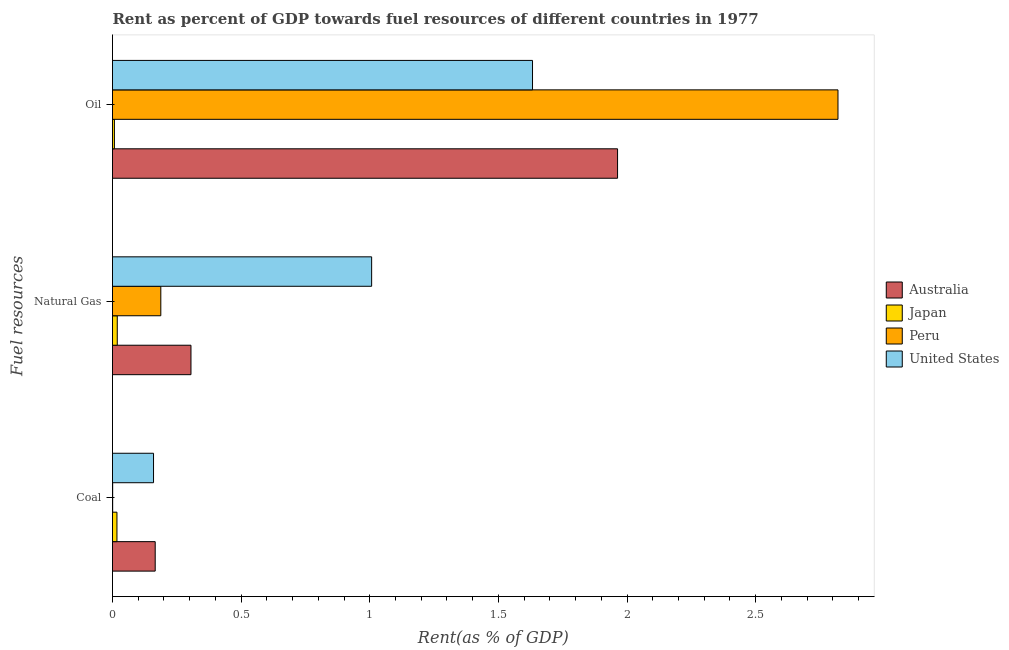How many groups of bars are there?
Provide a succinct answer. 3. What is the label of the 1st group of bars from the top?
Give a very brief answer. Oil. What is the rent towards oil in Japan?
Provide a succinct answer. 0.01. Across all countries, what is the maximum rent towards coal?
Provide a succinct answer. 0.17. Across all countries, what is the minimum rent towards natural gas?
Provide a succinct answer. 0.02. In which country was the rent towards oil maximum?
Your response must be concise. Peru. What is the total rent towards natural gas in the graph?
Offer a terse response. 1.52. What is the difference between the rent towards natural gas in United States and that in Australia?
Keep it short and to the point. 0.7. What is the difference between the rent towards coal in Peru and the rent towards natural gas in United States?
Your answer should be very brief. -1.01. What is the average rent towards oil per country?
Provide a succinct answer. 1.61. What is the difference between the rent towards natural gas and rent towards coal in Australia?
Give a very brief answer. 0.14. In how many countries, is the rent towards coal greater than 0.5 %?
Keep it short and to the point. 0. What is the ratio of the rent towards coal in Japan to that in United States?
Your answer should be compact. 0.11. What is the difference between the highest and the second highest rent towards natural gas?
Give a very brief answer. 0.7. What is the difference between the highest and the lowest rent towards coal?
Give a very brief answer. 0.17. In how many countries, is the rent towards natural gas greater than the average rent towards natural gas taken over all countries?
Keep it short and to the point. 1. Is the sum of the rent towards natural gas in Japan and United States greater than the maximum rent towards coal across all countries?
Your answer should be very brief. Yes. What does the 3rd bar from the bottom in Natural Gas represents?
Provide a succinct answer. Peru. Are all the bars in the graph horizontal?
Offer a terse response. Yes. Does the graph contain any zero values?
Your answer should be compact. No. Does the graph contain grids?
Ensure brevity in your answer.  No. What is the title of the graph?
Offer a very short reply. Rent as percent of GDP towards fuel resources of different countries in 1977. What is the label or title of the X-axis?
Offer a terse response. Rent(as % of GDP). What is the label or title of the Y-axis?
Give a very brief answer. Fuel resources. What is the Rent(as % of GDP) in Australia in Coal?
Provide a succinct answer. 0.17. What is the Rent(as % of GDP) of Japan in Coal?
Your answer should be very brief. 0.02. What is the Rent(as % of GDP) of Peru in Coal?
Provide a short and direct response. 0. What is the Rent(as % of GDP) in United States in Coal?
Your answer should be compact. 0.16. What is the Rent(as % of GDP) in Australia in Natural Gas?
Provide a short and direct response. 0.31. What is the Rent(as % of GDP) of Japan in Natural Gas?
Provide a succinct answer. 0.02. What is the Rent(as % of GDP) in Peru in Natural Gas?
Your answer should be very brief. 0.19. What is the Rent(as % of GDP) in United States in Natural Gas?
Provide a succinct answer. 1.01. What is the Rent(as % of GDP) of Australia in Oil?
Keep it short and to the point. 1.96. What is the Rent(as % of GDP) of Japan in Oil?
Give a very brief answer. 0.01. What is the Rent(as % of GDP) of Peru in Oil?
Your answer should be very brief. 2.82. What is the Rent(as % of GDP) of United States in Oil?
Offer a terse response. 1.63. Across all Fuel resources, what is the maximum Rent(as % of GDP) of Australia?
Your answer should be very brief. 1.96. Across all Fuel resources, what is the maximum Rent(as % of GDP) in Japan?
Offer a terse response. 0.02. Across all Fuel resources, what is the maximum Rent(as % of GDP) of Peru?
Provide a short and direct response. 2.82. Across all Fuel resources, what is the maximum Rent(as % of GDP) of United States?
Your answer should be compact. 1.63. Across all Fuel resources, what is the minimum Rent(as % of GDP) of Australia?
Give a very brief answer. 0.17. Across all Fuel resources, what is the minimum Rent(as % of GDP) of Japan?
Offer a very short reply. 0.01. Across all Fuel resources, what is the minimum Rent(as % of GDP) of Peru?
Your answer should be very brief. 0. Across all Fuel resources, what is the minimum Rent(as % of GDP) of United States?
Offer a terse response. 0.16. What is the total Rent(as % of GDP) of Australia in the graph?
Keep it short and to the point. 2.43. What is the total Rent(as % of GDP) of Japan in the graph?
Your response must be concise. 0.04. What is the total Rent(as % of GDP) of Peru in the graph?
Your response must be concise. 3.01. What is the total Rent(as % of GDP) of United States in the graph?
Provide a short and direct response. 2.8. What is the difference between the Rent(as % of GDP) in Australia in Coal and that in Natural Gas?
Keep it short and to the point. -0.14. What is the difference between the Rent(as % of GDP) of Japan in Coal and that in Natural Gas?
Make the answer very short. -0. What is the difference between the Rent(as % of GDP) of Peru in Coal and that in Natural Gas?
Give a very brief answer. -0.19. What is the difference between the Rent(as % of GDP) in United States in Coal and that in Natural Gas?
Ensure brevity in your answer.  -0.85. What is the difference between the Rent(as % of GDP) in Australia in Coal and that in Oil?
Provide a short and direct response. -1.8. What is the difference between the Rent(as % of GDP) of Japan in Coal and that in Oil?
Offer a terse response. 0.01. What is the difference between the Rent(as % of GDP) in Peru in Coal and that in Oil?
Give a very brief answer. -2.82. What is the difference between the Rent(as % of GDP) of United States in Coal and that in Oil?
Make the answer very short. -1.47. What is the difference between the Rent(as % of GDP) of Australia in Natural Gas and that in Oil?
Provide a short and direct response. -1.66. What is the difference between the Rent(as % of GDP) in Japan in Natural Gas and that in Oil?
Your response must be concise. 0.01. What is the difference between the Rent(as % of GDP) in Peru in Natural Gas and that in Oil?
Offer a very short reply. -2.63. What is the difference between the Rent(as % of GDP) of United States in Natural Gas and that in Oil?
Give a very brief answer. -0.63. What is the difference between the Rent(as % of GDP) of Australia in Coal and the Rent(as % of GDP) of Japan in Natural Gas?
Your answer should be very brief. 0.15. What is the difference between the Rent(as % of GDP) of Australia in Coal and the Rent(as % of GDP) of Peru in Natural Gas?
Give a very brief answer. -0.02. What is the difference between the Rent(as % of GDP) of Australia in Coal and the Rent(as % of GDP) of United States in Natural Gas?
Make the answer very short. -0.84. What is the difference between the Rent(as % of GDP) in Japan in Coal and the Rent(as % of GDP) in Peru in Natural Gas?
Ensure brevity in your answer.  -0.17. What is the difference between the Rent(as % of GDP) of Japan in Coal and the Rent(as % of GDP) of United States in Natural Gas?
Make the answer very short. -0.99. What is the difference between the Rent(as % of GDP) of Peru in Coal and the Rent(as % of GDP) of United States in Natural Gas?
Give a very brief answer. -1.01. What is the difference between the Rent(as % of GDP) in Australia in Coal and the Rent(as % of GDP) in Japan in Oil?
Your answer should be very brief. 0.16. What is the difference between the Rent(as % of GDP) in Australia in Coal and the Rent(as % of GDP) in Peru in Oil?
Keep it short and to the point. -2.65. What is the difference between the Rent(as % of GDP) of Australia in Coal and the Rent(as % of GDP) of United States in Oil?
Make the answer very short. -1.47. What is the difference between the Rent(as % of GDP) of Japan in Coal and the Rent(as % of GDP) of Peru in Oil?
Provide a short and direct response. -2.8. What is the difference between the Rent(as % of GDP) of Japan in Coal and the Rent(as % of GDP) of United States in Oil?
Ensure brevity in your answer.  -1.62. What is the difference between the Rent(as % of GDP) in Peru in Coal and the Rent(as % of GDP) in United States in Oil?
Make the answer very short. -1.63. What is the difference between the Rent(as % of GDP) of Australia in Natural Gas and the Rent(as % of GDP) of Japan in Oil?
Offer a very short reply. 0.3. What is the difference between the Rent(as % of GDP) in Australia in Natural Gas and the Rent(as % of GDP) in Peru in Oil?
Offer a very short reply. -2.52. What is the difference between the Rent(as % of GDP) in Australia in Natural Gas and the Rent(as % of GDP) in United States in Oil?
Make the answer very short. -1.33. What is the difference between the Rent(as % of GDP) of Japan in Natural Gas and the Rent(as % of GDP) of Peru in Oil?
Give a very brief answer. -2.8. What is the difference between the Rent(as % of GDP) of Japan in Natural Gas and the Rent(as % of GDP) of United States in Oil?
Give a very brief answer. -1.61. What is the difference between the Rent(as % of GDP) in Peru in Natural Gas and the Rent(as % of GDP) in United States in Oil?
Provide a short and direct response. -1.44. What is the average Rent(as % of GDP) of Australia per Fuel resources?
Your response must be concise. 0.81. What is the average Rent(as % of GDP) of Japan per Fuel resources?
Offer a terse response. 0.01. What is the average Rent(as % of GDP) of United States per Fuel resources?
Your answer should be very brief. 0.93. What is the difference between the Rent(as % of GDP) in Australia and Rent(as % of GDP) in Japan in Coal?
Ensure brevity in your answer.  0.15. What is the difference between the Rent(as % of GDP) in Australia and Rent(as % of GDP) in Peru in Coal?
Provide a short and direct response. 0.17. What is the difference between the Rent(as % of GDP) of Australia and Rent(as % of GDP) of United States in Coal?
Provide a short and direct response. 0.01. What is the difference between the Rent(as % of GDP) of Japan and Rent(as % of GDP) of Peru in Coal?
Ensure brevity in your answer.  0.02. What is the difference between the Rent(as % of GDP) in Japan and Rent(as % of GDP) in United States in Coal?
Provide a short and direct response. -0.14. What is the difference between the Rent(as % of GDP) in Peru and Rent(as % of GDP) in United States in Coal?
Your answer should be very brief. -0.16. What is the difference between the Rent(as % of GDP) of Australia and Rent(as % of GDP) of Japan in Natural Gas?
Offer a terse response. 0.29. What is the difference between the Rent(as % of GDP) in Australia and Rent(as % of GDP) in Peru in Natural Gas?
Your answer should be compact. 0.12. What is the difference between the Rent(as % of GDP) in Australia and Rent(as % of GDP) in United States in Natural Gas?
Provide a short and direct response. -0.7. What is the difference between the Rent(as % of GDP) in Japan and Rent(as % of GDP) in Peru in Natural Gas?
Your response must be concise. -0.17. What is the difference between the Rent(as % of GDP) of Japan and Rent(as % of GDP) of United States in Natural Gas?
Your response must be concise. -0.99. What is the difference between the Rent(as % of GDP) of Peru and Rent(as % of GDP) of United States in Natural Gas?
Your response must be concise. -0.82. What is the difference between the Rent(as % of GDP) in Australia and Rent(as % of GDP) in Japan in Oil?
Provide a succinct answer. 1.96. What is the difference between the Rent(as % of GDP) of Australia and Rent(as % of GDP) of Peru in Oil?
Give a very brief answer. -0.86. What is the difference between the Rent(as % of GDP) of Australia and Rent(as % of GDP) of United States in Oil?
Your response must be concise. 0.33. What is the difference between the Rent(as % of GDP) of Japan and Rent(as % of GDP) of Peru in Oil?
Offer a terse response. -2.81. What is the difference between the Rent(as % of GDP) of Japan and Rent(as % of GDP) of United States in Oil?
Ensure brevity in your answer.  -1.63. What is the difference between the Rent(as % of GDP) in Peru and Rent(as % of GDP) in United States in Oil?
Ensure brevity in your answer.  1.19. What is the ratio of the Rent(as % of GDP) of Australia in Coal to that in Natural Gas?
Provide a short and direct response. 0.54. What is the ratio of the Rent(as % of GDP) in Japan in Coal to that in Natural Gas?
Offer a very short reply. 0.94. What is the ratio of the Rent(as % of GDP) of Peru in Coal to that in Natural Gas?
Offer a very short reply. 0. What is the ratio of the Rent(as % of GDP) in United States in Coal to that in Natural Gas?
Offer a very short reply. 0.16. What is the ratio of the Rent(as % of GDP) of Australia in Coal to that in Oil?
Offer a terse response. 0.08. What is the ratio of the Rent(as % of GDP) in Japan in Coal to that in Oil?
Provide a short and direct response. 2.34. What is the ratio of the Rent(as % of GDP) of United States in Coal to that in Oil?
Offer a very short reply. 0.1. What is the ratio of the Rent(as % of GDP) of Australia in Natural Gas to that in Oil?
Give a very brief answer. 0.16. What is the ratio of the Rent(as % of GDP) in Japan in Natural Gas to that in Oil?
Give a very brief answer. 2.5. What is the ratio of the Rent(as % of GDP) of Peru in Natural Gas to that in Oil?
Offer a terse response. 0.07. What is the ratio of the Rent(as % of GDP) of United States in Natural Gas to that in Oil?
Your response must be concise. 0.62. What is the difference between the highest and the second highest Rent(as % of GDP) of Australia?
Make the answer very short. 1.66. What is the difference between the highest and the second highest Rent(as % of GDP) of Japan?
Your answer should be very brief. 0. What is the difference between the highest and the second highest Rent(as % of GDP) in Peru?
Ensure brevity in your answer.  2.63. What is the difference between the highest and the second highest Rent(as % of GDP) in United States?
Your answer should be very brief. 0.63. What is the difference between the highest and the lowest Rent(as % of GDP) in Australia?
Offer a terse response. 1.8. What is the difference between the highest and the lowest Rent(as % of GDP) of Japan?
Provide a short and direct response. 0.01. What is the difference between the highest and the lowest Rent(as % of GDP) of Peru?
Your answer should be compact. 2.82. What is the difference between the highest and the lowest Rent(as % of GDP) of United States?
Your answer should be very brief. 1.47. 